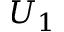Convert formula to latex. <formula><loc_0><loc_0><loc_500><loc_500>U _ { 1 }</formula> 